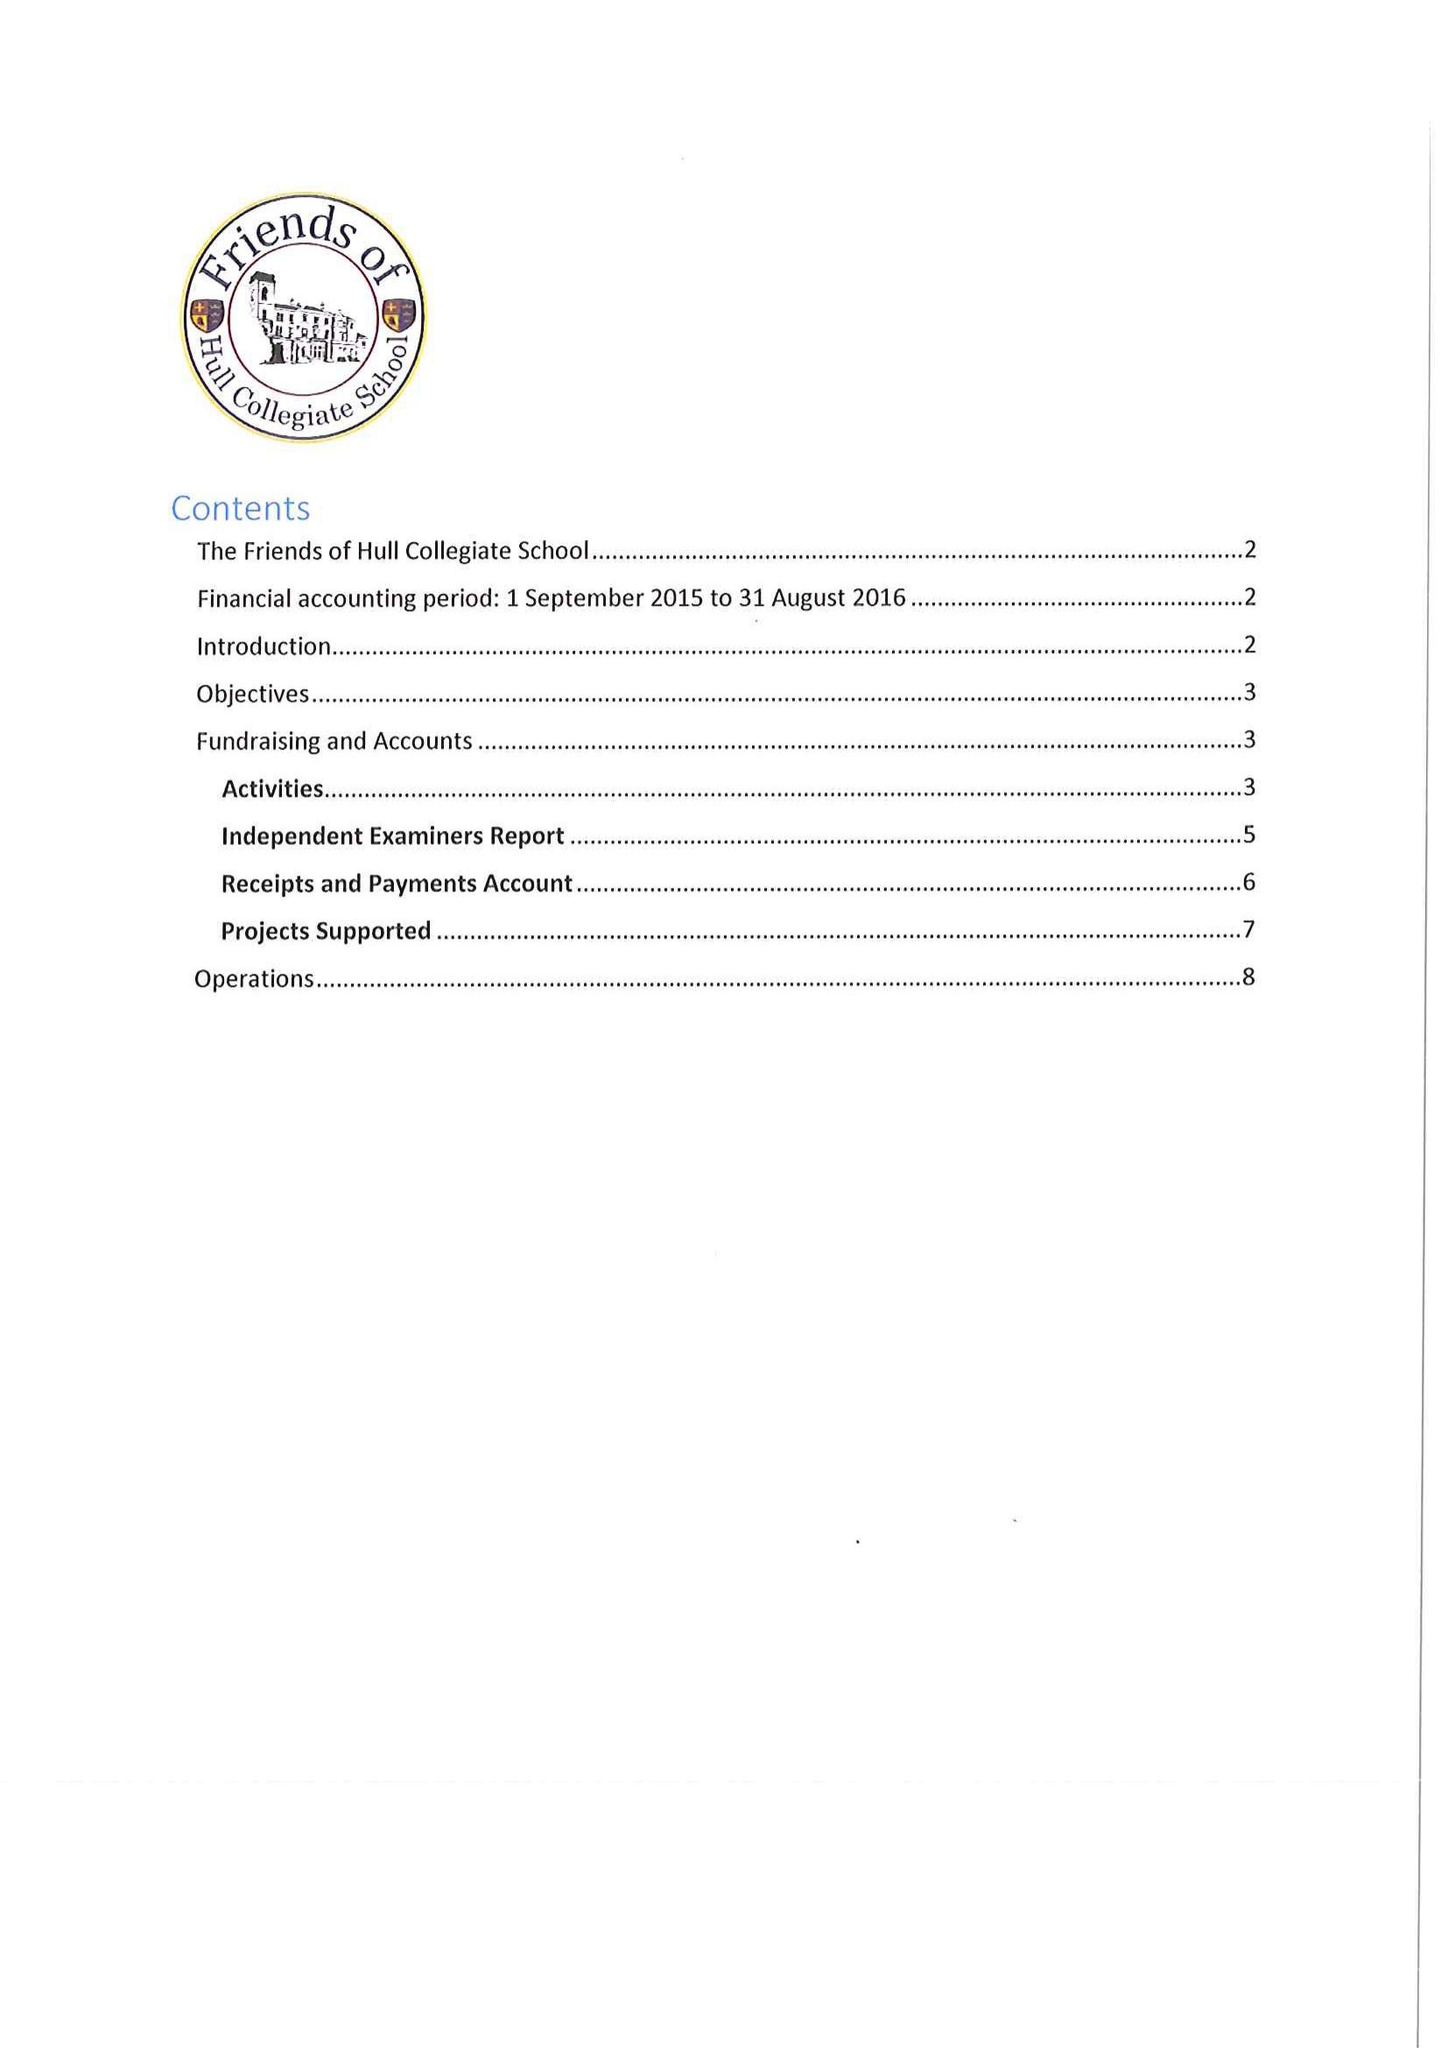What is the value for the report_date?
Answer the question using a single word or phrase. 2016-08-31 